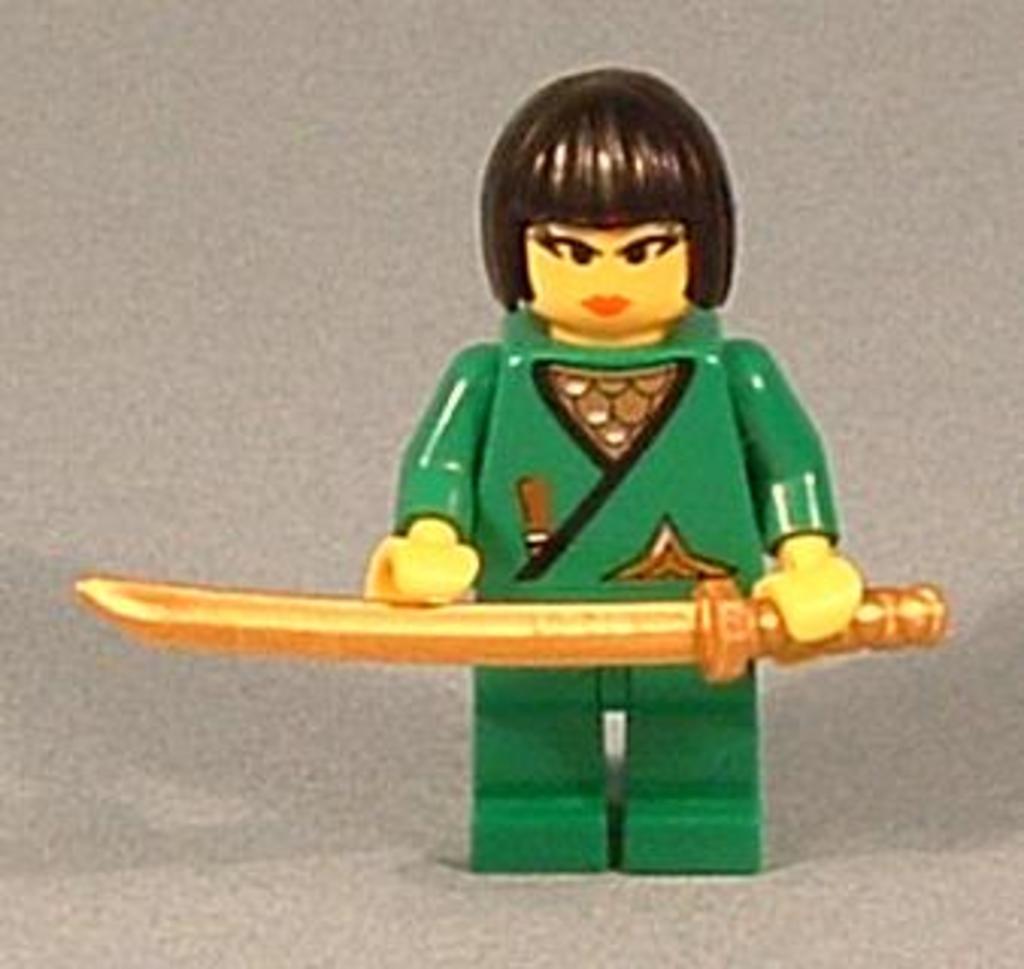Can you describe this image briefly? It is an animated image of a girl holding the knife, she wore green color dress. 